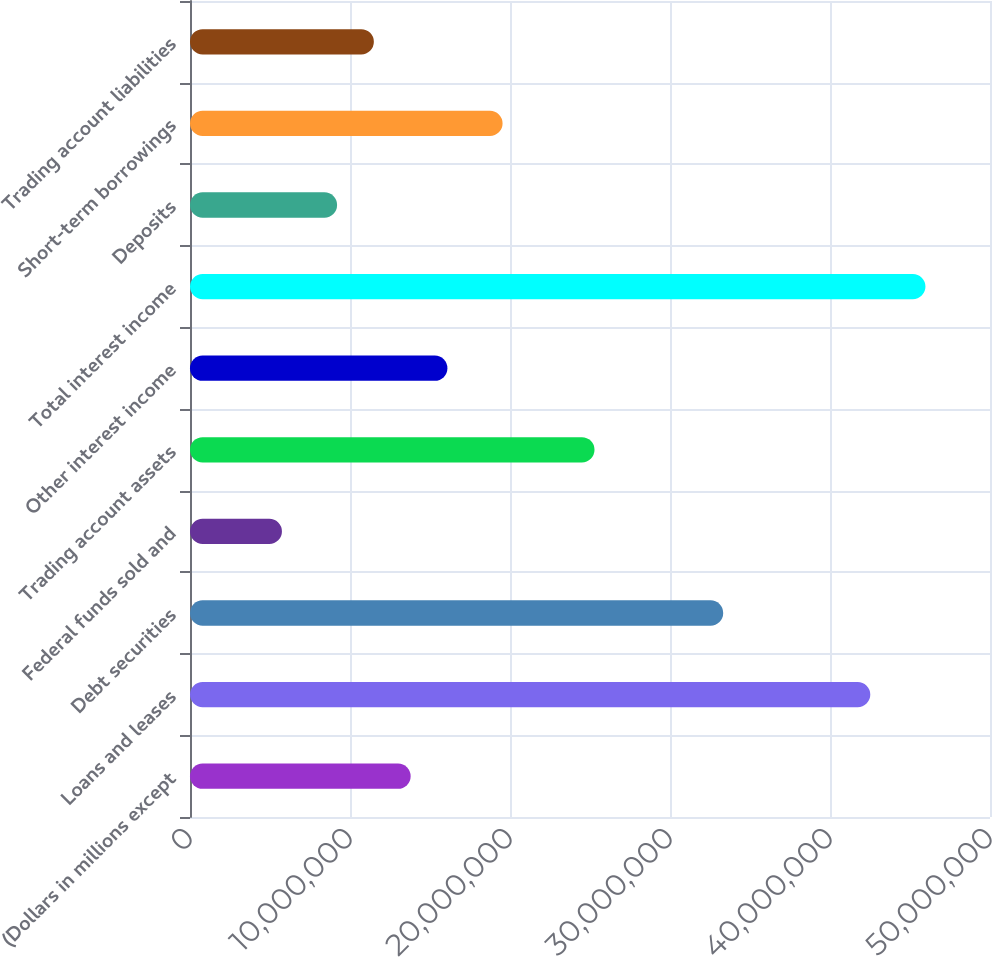Convert chart. <chart><loc_0><loc_0><loc_500><loc_500><bar_chart><fcel>(Dollars in millions except<fcel>Loans and leases<fcel>Debt securities<fcel>Federal funds sold and<fcel>Trading account assets<fcel>Other interest income<fcel>Total interest income<fcel>Deposits<fcel>Short-term borrowings<fcel>Trading account liabilities<nl><fcel>1.37897e+07<fcel>4.25182e+07<fcel>3.33251e+07<fcel>5.74571e+06<fcel>2.52811e+07<fcel>1.6088e+07<fcel>4.59657e+07<fcel>9.19313e+06<fcel>1.95354e+07<fcel>1.14914e+07<nl></chart> 